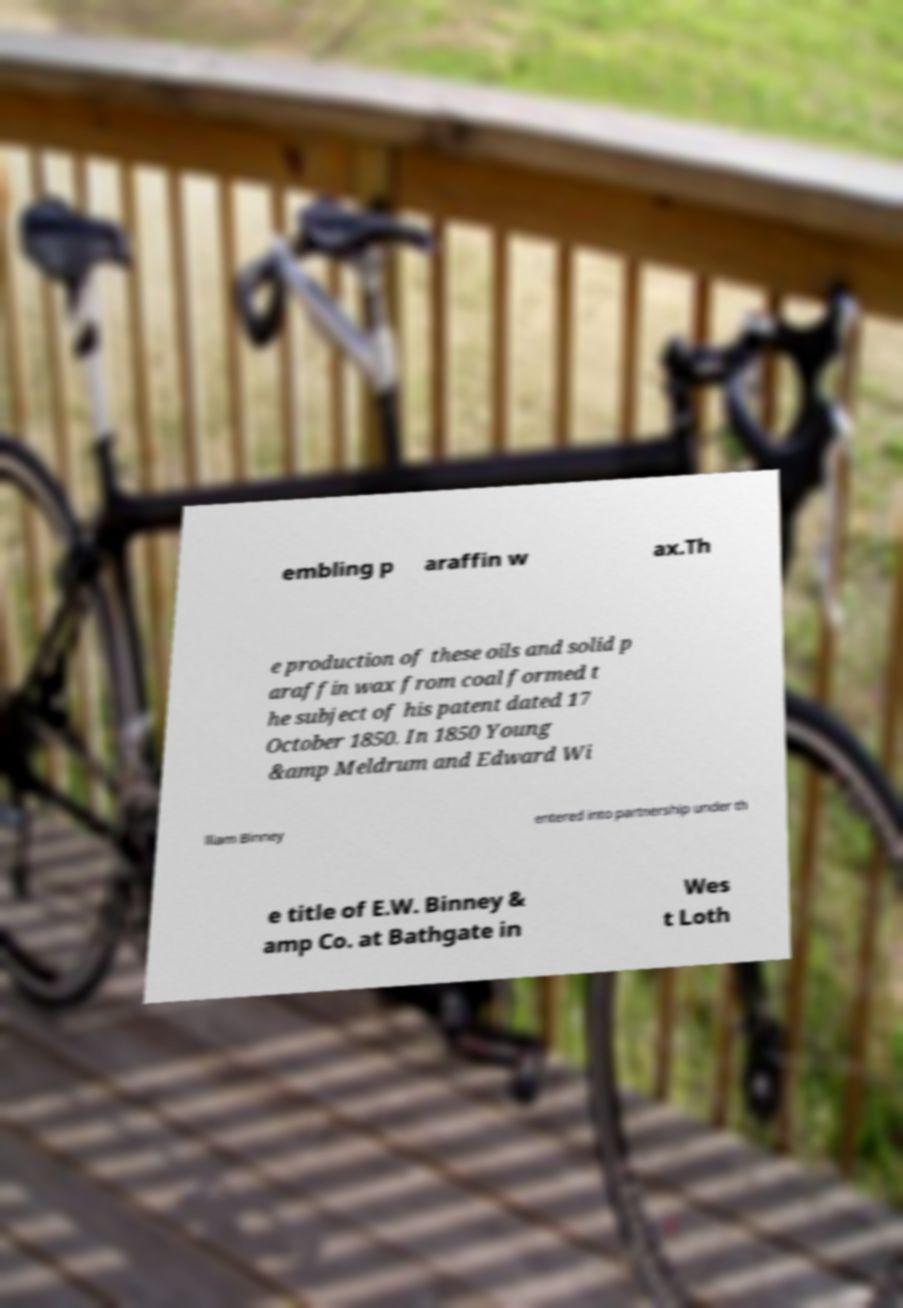Can you read and provide the text displayed in the image?This photo seems to have some interesting text. Can you extract and type it out for me? embling p araffin w ax.Th e production of these oils and solid p araffin wax from coal formed t he subject of his patent dated 17 October 1850. In 1850 Young &amp Meldrum and Edward Wi lliam Binney entered into partnership under th e title of E.W. Binney & amp Co. at Bathgate in Wes t Loth 